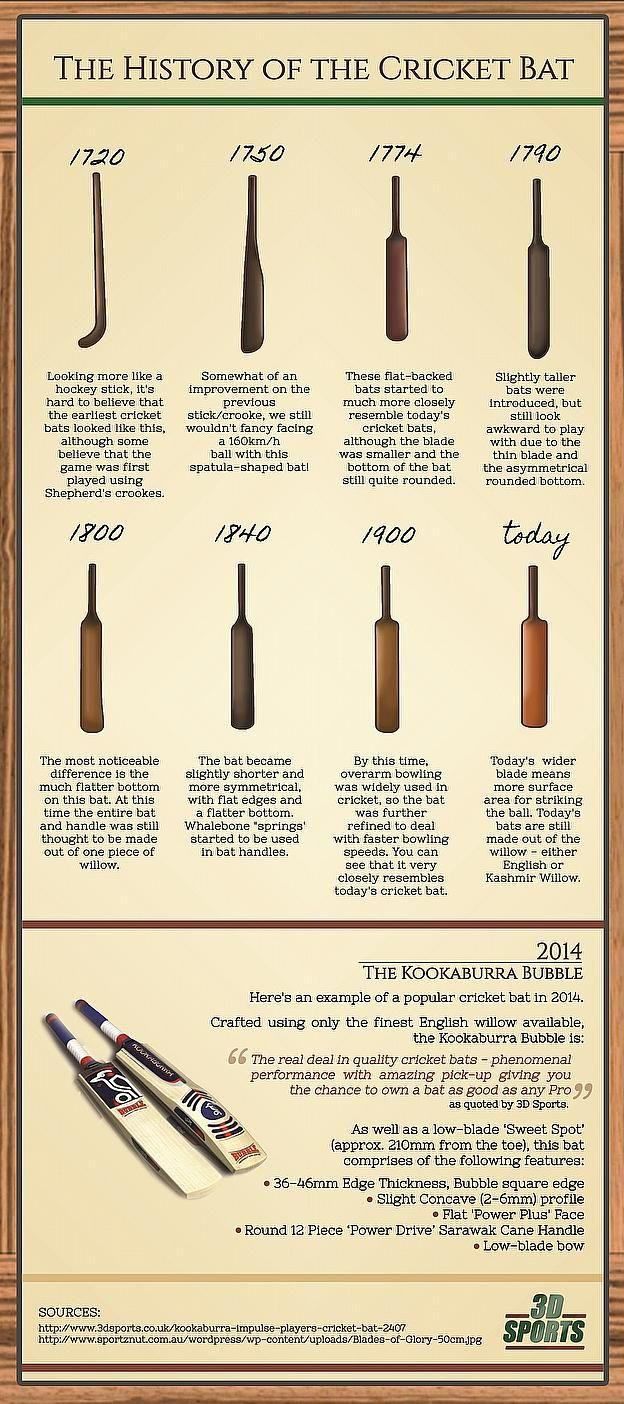List a handful of essential elements in this visual. During the period of 1720, the cricket bat resembled a pusher. The brand name written on the cricket bat is Kookaburra. The cricket bat began to resemble a wooden turner around the year 1750. 